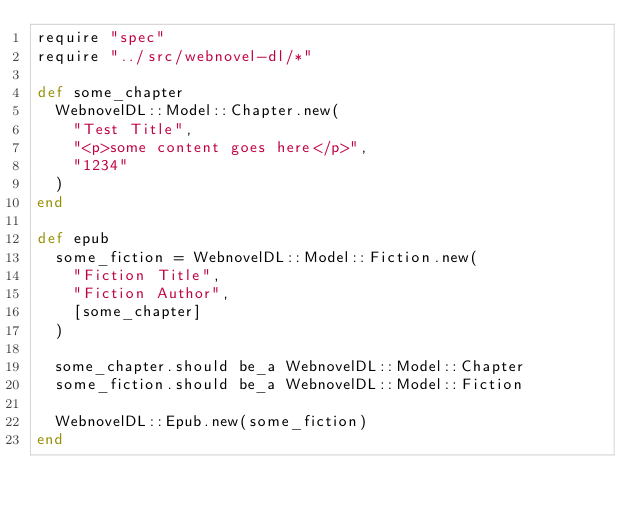Convert code to text. <code><loc_0><loc_0><loc_500><loc_500><_Crystal_>require "spec"
require "../src/webnovel-dl/*"

def some_chapter
  WebnovelDL::Model::Chapter.new(
    "Test Title",
    "<p>some content goes here</p>",
    "1234"
  )
end

def epub
  some_fiction = WebnovelDL::Model::Fiction.new(
    "Fiction Title",
    "Fiction Author",
    [some_chapter]
  )

  some_chapter.should be_a WebnovelDL::Model::Chapter
  some_fiction.should be_a WebnovelDL::Model::Fiction

  WebnovelDL::Epub.new(some_fiction)
end
</code> 